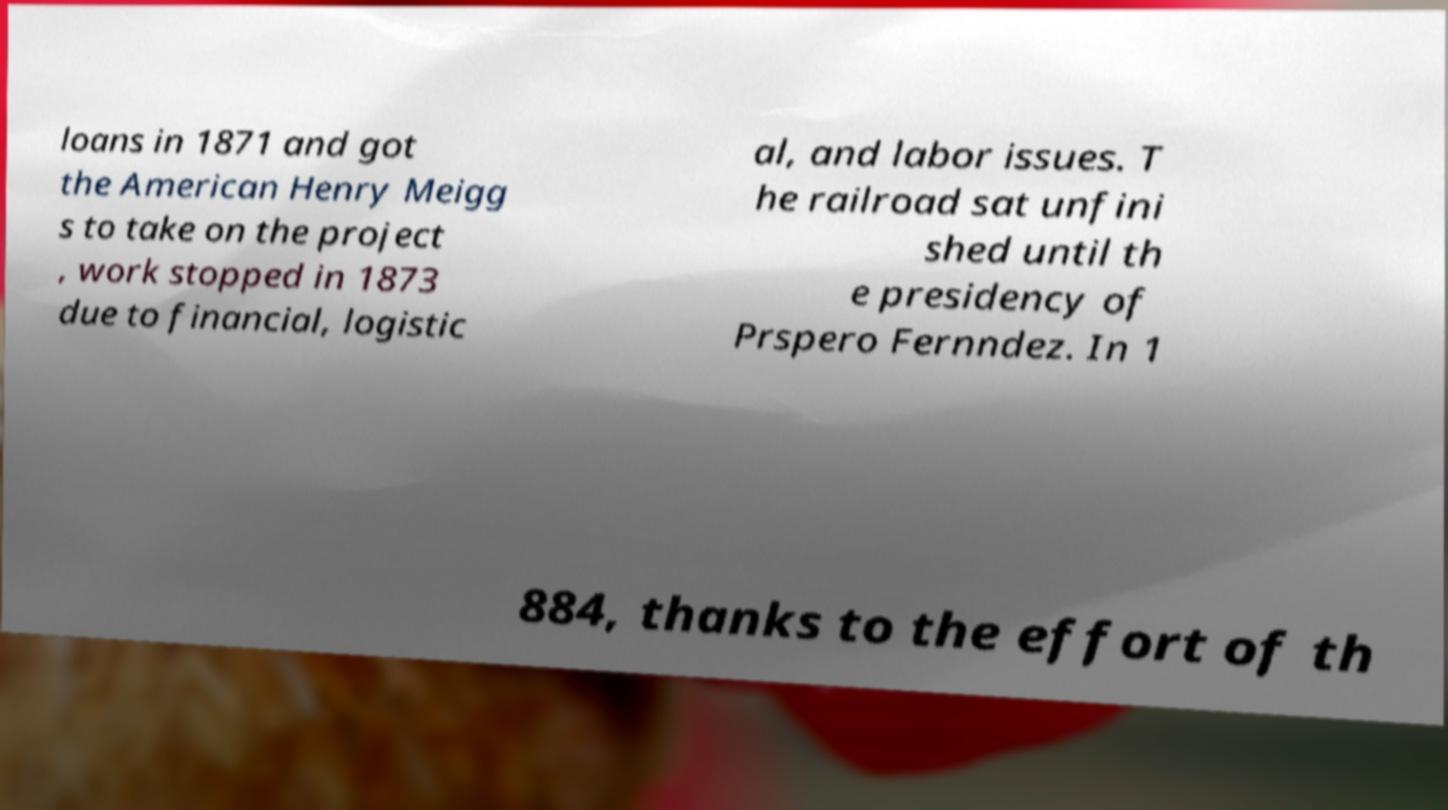Can you read and provide the text displayed in the image?This photo seems to have some interesting text. Can you extract and type it out for me? loans in 1871 and got the American Henry Meigg s to take on the project , work stopped in 1873 due to financial, logistic al, and labor issues. T he railroad sat unfini shed until th e presidency of Prspero Fernndez. In 1 884, thanks to the effort of th 